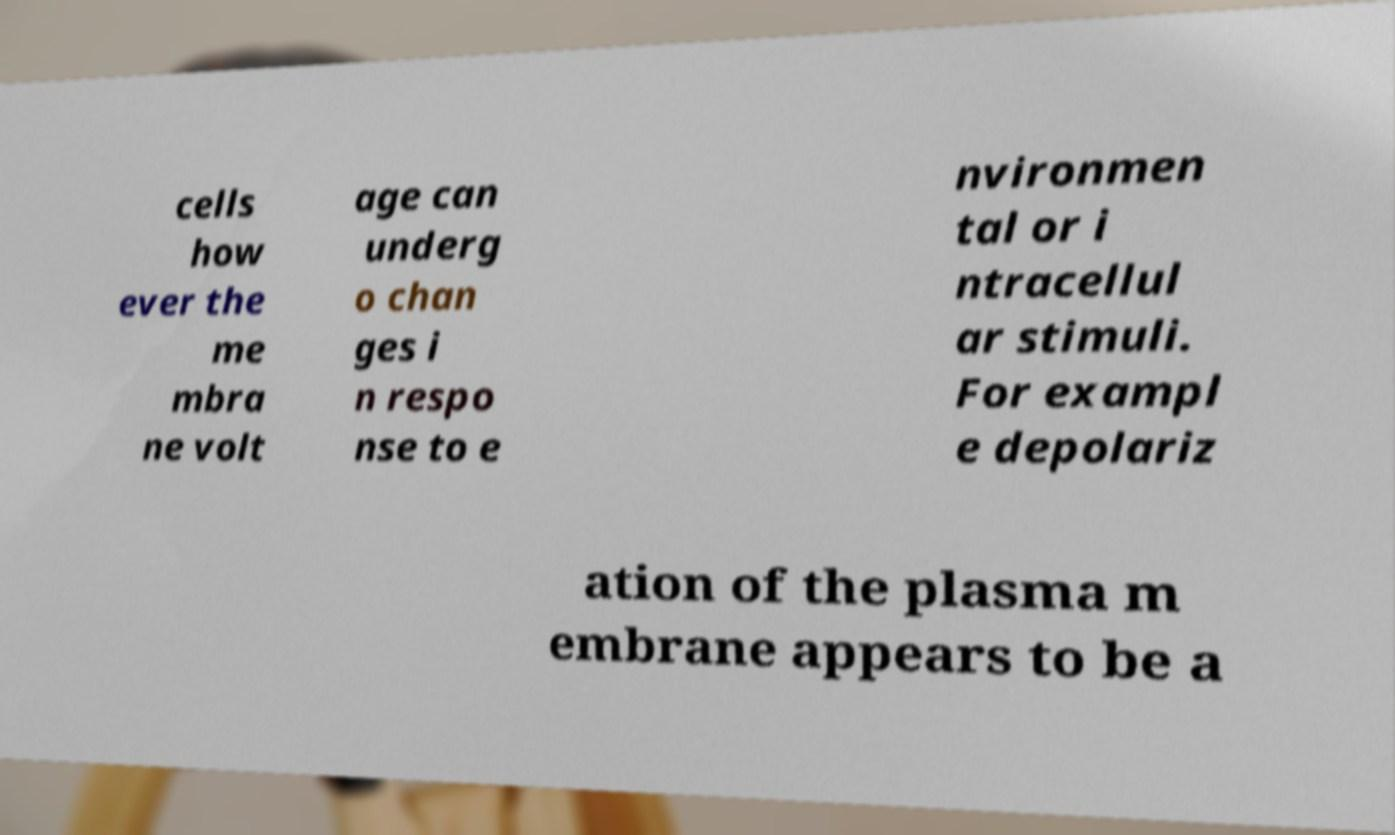For documentation purposes, I need the text within this image transcribed. Could you provide that? cells how ever the me mbra ne volt age can underg o chan ges i n respo nse to e nvironmen tal or i ntracellul ar stimuli. For exampl e depolariz ation of the plasma m embrane appears to be a 